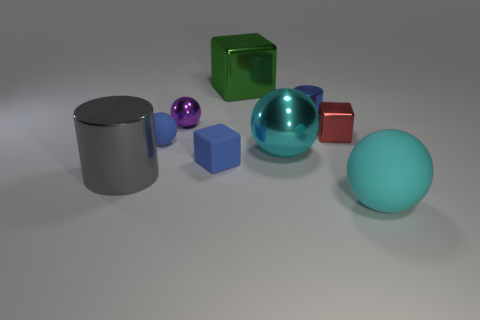Can you describe the lighting and shadows in the scene? Certainly. The lighting in the image is diffused, producing soft shadows under each object. It appears to come from a high angle based on the shadow placement, suggesting an overhead light source, not directly above but slightly to the front. The shadows are not very dark, which implies that there may be several sources of light or a large light with a broad cast, softening the shadows. 